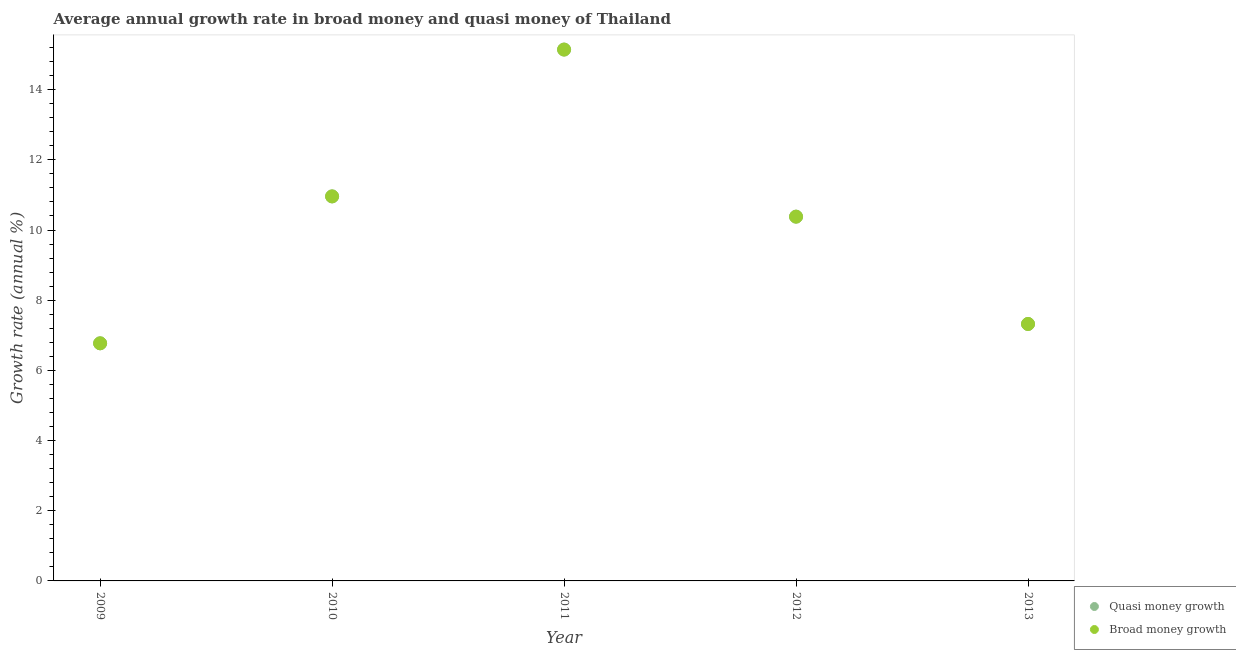How many different coloured dotlines are there?
Your answer should be compact. 2. What is the annual growth rate in broad money in 2012?
Provide a short and direct response. 10.38. Across all years, what is the maximum annual growth rate in broad money?
Offer a terse response. 15.14. Across all years, what is the minimum annual growth rate in quasi money?
Provide a short and direct response. 6.77. What is the total annual growth rate in broad money in the graph?
Keep it short and to the point. 50.57. What is the difference between the annual growth rate in quasi money in 2009 and that in 2010?
Make the answer very short. -4.19. What is the difference between the annual growth rate in broad money in 2013 and the annual growth rate in quasi money in 2012?
Your answer should be compact. -3.06. What is the average annual growth rate in quasi money per year?
Your answer should be compact. 10.11. In the year 2012, what is the difference between the annual growth rate in broad money and annual growth rate in quasi money?
Your answer should be very brief. 0. In how many years, is the annual growth rate in broad money greater than 10.8 %?
Make the answer very short. 2. What is the ratio of the annual growth rate in quasi money in 2009 to that in 2012?
Your answer should be very brief. 0.65. Is the annual growth rate in broad money in 2010 less than that in 2011?
Give a very brief answer. Yes. What is the difference between the highest and the second highest annual growth rate in broad money?
Your answer should be compact. 4.18. What is the difference between the highest and the lowest annual growth rate in broad money?
Ensure brevity in your answer.  8.37. Does the annual growth rate in quasi money monotonically increase over the years?
Make the answer very short. No. Is the annual growth rate in quasi money strictly greater than the annual growth rate in broad money over the years?
Provide a succinct answer. No. What is the difference between two consecutive major ticks on the Y-axis?
Your response must be concise. 2. Are the values on the major ticks of Y-axis written in scientific E-notation?
Ensure brevity in your answer.  No. Does the graph contain grids?
Your response must be concise. No. How are the legend labels stacked?
Give a very brief answer. Vertical. What is the title of the graph?
Ensure brevity in your answer.  Average annual growth rate in broad money and quasi money of Thailand. What is the label or title of the X-axis?
Offer a very short reply. Year. What is the label or title of the Y-axis?
Your answer should be very brief. Growth rate (annual %). What is the Growth rate (annual %) in Quasi money growth in 2009?
Keep it short and to the point. 6.77. What is the Growth rate (annual %) in Broad money growth in 2009?
Keep it short and to the point. 6.77. What is the Growth rate (annual %) of Quasi money growth in 2010?
Your answer should be very brief. 10.96. What is the Growth rate (annual %) of Broad money growth in 2010?
Your answer should be very brief. 10.96. What is the Growth rate (annual %) of Quasi money growth in 2011?
Offer a very short reply. 15.14. What is the Growth rate (annual %) of Broad money growth in 2011?
Your response must be concise. 15.14. What is the Growth rate (annual %) in Quasi money growth in 2012?
Your response must be concise. 10.38. What is the Growth rate (annual %) of Broad money growth in 2012?
Offer a very short reply. 10.38. What is the Growth rate (annual %) in Quasi money growth in 2013?
Provide a succinct answer. 7.32. What is the Growth rate (annual %) of Broad money growth in 2013?
Ensure brevity in your answer.  7.32. Across all years, what is the maximum Growth rate (annual %) in Quasi money growth?
Offer a terse response. 15.14. Across all years, what is the maximum Growth rate (annual %) in Broad money growth?
Offer a very short reply. 15.14. Across all years, what is the minimum Growth rate (annual %) of Quasi money growth?
Your answer should be very brief. 6.77. Across all years, what is the minimum Growth rate (annual %) of Broad money growth?
Ensure brevity in your answer.  6.77. What is the total Growth rate (annual %) of Quasi money growth in the graph?
Ensure brevity in your answer.  50.57. What is the total Growth rate (annual %) of Broad money growth in the graph?
Ensure brevity in your answer.  50.57. What is the difference between the Growth rate (annual %) in Quasi money growth in 2009 and that in 2010?
Make the answer very short. -4.19. What is the difference between the Growth rate (annual %) in Broad money growth in 2009 and that in 2010?
Offer a terse response. -4.19. What is the difference between the Growth rate (annual %) of Quasi money growth in 2009 and that in 2011?
Make the answer very short. -8.37. What is the difference between the Growth rate (annual %) in Broad money growth in 2009 and that in 2011?
Your answer should be very brief. -8.37. What is the difference between the Growth rate (annual %) of Quasi money growth in 2009 and that in 2012?
Give a very brief answer. -3.61. What is the difference between the Growth rate (annual %) of Broad money growth in 2009 and that in 2012?
Keep it short and to the point. -3.61. What is the difference between the Growth rate (annual %) in Quasi money growth in 2009 and that in 2013?
Ensure brevity in your answer.  -0.55. What is the difference between the Growth rate (annual %) of Broad money growth in 2009 and that in 2013?
Keep it short and to the point. -0.55. What is the difference between the Growth rate (annual %) of Quasi money growth in 2010 and that in 2011?
Offer a very short reply. -4.18. What is the difference between the Growth rate (annual %) of Broad money growth in 2010 and that in 2011?
Offer a very short reply. -4.18. What is the difference between the Growth rate (annual %) of Quasi money growth in 2010 and that in 2012?
Your answer should be compact. 0.58. What is the difference between the Growth rate (annual %) in Broad money growth in 2010 and that in 2012?
Keep it short and to the point. 0.58. What is the difference between the Growth rate (annual %) of Quasi money growth in 2010 and that in 2013?
Provide a succinct answer. 3.64. What is the difference between the Growth rate (annual %) in Broad money growth in 2010 and that in 2013?
Your response must be concise. 3.64. What is the difference between the Growth rate (annual %) in Quasi money growth in 2011 and that in 2012?
Provide a succinct answer. 4.76. What is the difference between the Growth rate (annual %) of Broad money growth in 2011 and that in 2012?
Ensure brevity in your answer.  4.76. What is the difference between the Growth rate (annual %) of Quasi money growth in 2011 and that in 2013?
Your answer should be compact. 7.82. What is the difference between the Growth rate (annual %) of Broad money growth in 2011 and that in 2013?
Offer a terse response. 7.82. What is the difference between the Growth rate (annual %) in Quasi money growth in 2012 and that in 2013?
Your answer should be compact. 3.06. What is the difference between the Growth rate (annual %) of Broad money growth in 2012 and that in 2013?
Your answer should be very brief. 3.06. What is the difference between the Growth rate (annual %) of Quasi money growth in 2009 and the Growth rate (annual %) of Broad money growth in 2010?
Your answer should be compact. -4.19. What is the difference between the Growth rate (annual %) in Quasi money growth in 2009 and the Growth rate (annual %) in Broad money growth in 2011?
Your answer should be very brief. -8.37. What is the difference between the Growth rate (annual %) of Quasi money growth in 2009 and the Growth rate (annual %) of Broad money growth in 2012?
Ensure brevity in your answer.  -3.61. What is the difference between the Growth rate (annual %) of Quasi money growth in 2009 and the Growth rate (annual %) of Broad money growth in 2013?
Ensure brevity in your answer.  -0.55. What is the difference between the Growth rate (annual %) in Quasi money growth in 2010 and the Growth rate (annual %) in Broad money growth in 2011?
Offer a terse response. -4.18. What is the difference between the Growth rate (annual %) of Quasi money growth in 2010 and the Growth rate (annual %) of Broad money growth in 2012?
Your response must be concise. 0.58. What is the difference between the Growth rate (annual %) in Quasi money growth in 2010 and the Growth rate (annual %) in Broad money growth in 2013?
Provide a short and direct response. 3.64. What is the difference between the Growth rate (annual %) of Quasi money growth in 2011 and the Growth rate (annual %) of Broad money growth in 2012?
Offer a very short reply. 4.76. What is the difference between the Growth rate (annual %) of Quasi money growth in 2011 and the Growth rate (annual %) of Broad money growth in 2013?
Make the answer very short. 7.82. What is the difference between the Growth rate (annual %) in Quasi money growth in 2012 and the Growth rate (annual %) in Broad money growth in 2013?
Offer a terse response. 3.06. What is the average Growth rate (annual %) of Quasi money growth per year?
Offer a terse response. 10.11. What is the average Growth rate (annual %) in Broad money growth per year?
Your response must be concise. 10.11. In the year 2013, what is the difference between the Growth rate (annual %) of Quasi money growth and Growth rate (annual %) of Broad money growth?
Give a very brief answer. 0. What is the ratio of the Growth rate (annual %) of Quasi money growth in 2009 to that in 2010?
Your answer should be compact. 0.62. What is the ratio of the Growth rate (annual %) of Broad money growth in 2009 to that in 2010?
Provide a short and direct response. 0.62. What is the ratio of the Growth rate (annual %) in Quasi money growth in 2009 to that in 2011?
Your response must be concise. 0.45. What is the ratio of the Growth rate (annual %) in Broad money growth in 2009 to that in 2011?
Your answer should be compact. 0.45. What is the ratio of the Growth rate (annual %) of Quasi money growth in 2009 to that in 2012?
Your response must be concise. 0.65. What is the ratio of the Growth rate (annual %) in Broad money growth in 2009 to that in 2012?
Your answer should be compact. 0.65. What is the ratio of the Growth rate (annual %) in Quasi money growth in 2009 to that in 2013?
Offer a terse response. 0.92. What is the ratio of the Growth rate (annual %) in Broad money growth in 2009 to that in 2013?
Ensure brevity in your answer.  0.92. What is the ratio of the Growth rate (annual %) of Quasi money growth in 2010 to that in 2011?
Provide a short and direct response. 0.72. What is the ratio of the Growth rate (annual %) of Broad money growth in 2010 to that in 2011?
Provide a succinct answer. 0.72. What is the ratio of the Growth rate (annual %) of Quasi money growth in 2010 to that in 2012?
Give a very brief answer. 1.06. What is the ratio of the Growth rate (annual %) of Broad money growth in 2010 to that in 2012?
Your response must be concise. 1.06. What is the ratio of the Growth rate (annual %) of Quasi money growth in 2010 to that in 2013?
Provide a short and direct response. 1.5. What is the ratio of the Growth rate (annual %) of Broad money growth in 2010 to that in 2013?
Keep it short and to the point. 1.5. What is the ratio of the Growth rate (annual %) in Quasi money growth in 2011 to that in 2012?
Offer a very short reply. 1.46. What is the ratio of the Growth rate (annual %) of Broad money growth in 2011 to that in 2012?
Ensure brevity in your answer.  1.46. What is the ratio of the Growth rate (annual %) in Quasi money growth in 2011 to that in 2013?
Your response must be concise. 2.07. What is the ratio of the Growth rate (annual %) in Broad money growth in 2011 to that in 2013?
Offer a very short reply. 2.07. What is the ratio of the Growth rate (annual %) of Quasi money growth in 2012 to that in 2013?
Keep it short and to the point. 1.42. What is the ratio of the Growth rate (annual %) in Broad money growth in 2012 to that in 2013?
Provide a short and direct response. 1.42. What is the difference between the highest and the second highest Growth rate (annual %) of Quasi money growth?
Your response must be concise. 4.18. What is the difference between the highest and the second highest Growth rate (annual %) of Broad money growth?
Your response must be concise. 4.18. What is the difference between the highest and the lowest Growth rate (annual %) of Quasi money growth?
Offer a terse response. 8.37. What is the difference between the highest and the lowest Growth rate (annual %) of Broad money growth?
Offer a very short reply. 8.37. 